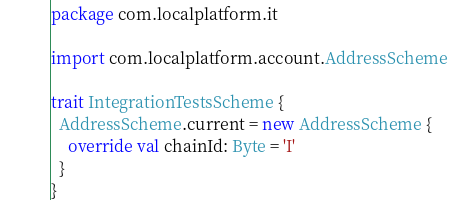Convert code to text. <code><loc_0><loc_0><loc_500><loc_500><_Scala_>package com.localplatform.it

import com.localplatform.account.AddressScheme

trait IntegrationTestsScheme {
  AddressScheme.current = new AddressScheme {
    override val chainId: Byte = 'I'
  }
}
</code> 